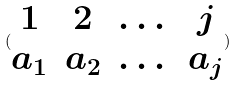Convert formula to latex. <formula><loc_0><loc_0><loc_500><loc_500>( \begin{matrix} 1 & 2 & \dots & j \\ a _ { 1 } & a _ { 2 } & \dots & a _ { j } \end{matrix} )</formula> 